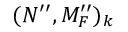<formula> <loc_0><loc_0><loc_500><loc_500>( N ^ { \prime \prime } , M _ { F } ^ { \prime \prime } ) _ { k }</formula> 